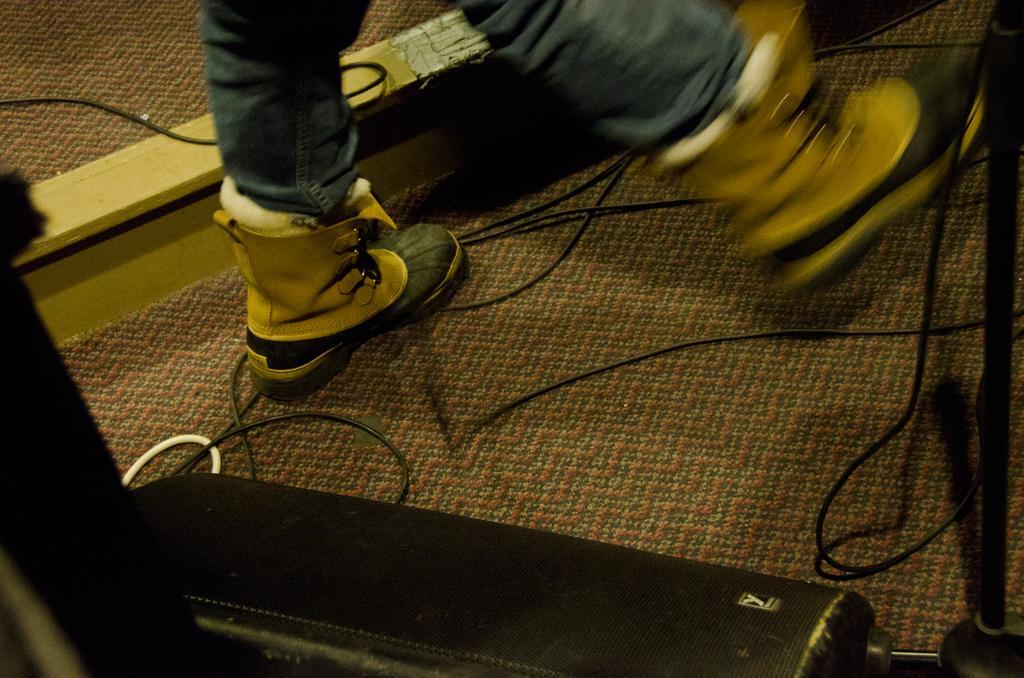In one or two sentences, can you explain what this image depicts? In this image there are legs of a person. There are shoes to the legs. On the floor there are cables, a box and a carpet. 